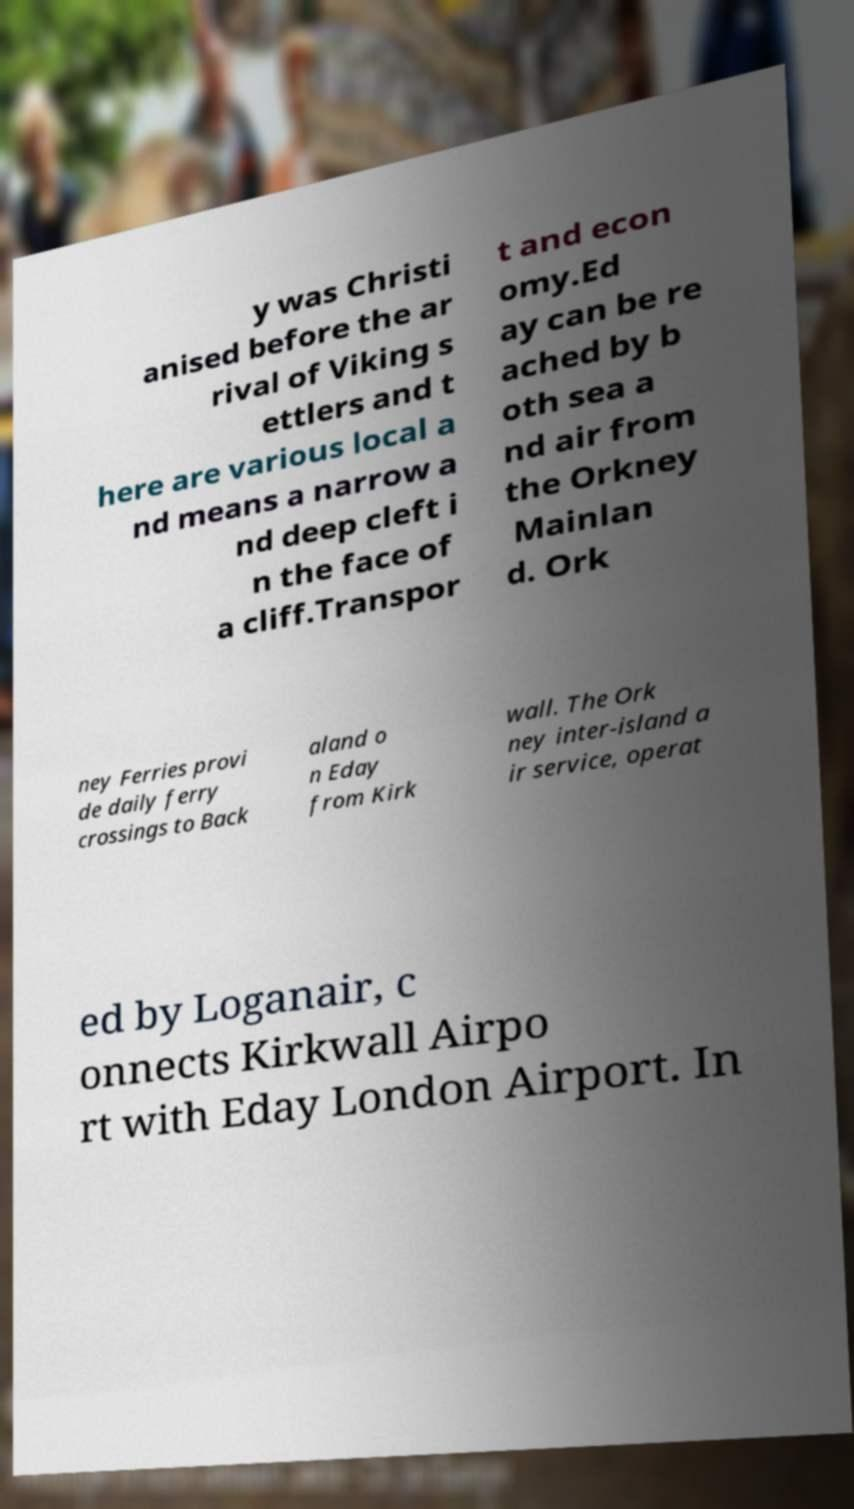Can you accurately transcribe the text from the provided image for me? y was Christi anised before the ar rival of Viking s ettlers and t here are various local a nd means a narrow a nd deep cleft i n the face of a cliff.Transpor t and econ omy.Ed ay can be re ached by b oth sea a nd air from the Orkney Mainlan d. Ork ney Ferries provi de daily ferry crossings to Back aland o n Eday from Kirk wall. The Ork ney inter-island a ir service, operat ed by Loganair, c onnects Kirkwall Airpo rt with Eday London Airport. In 